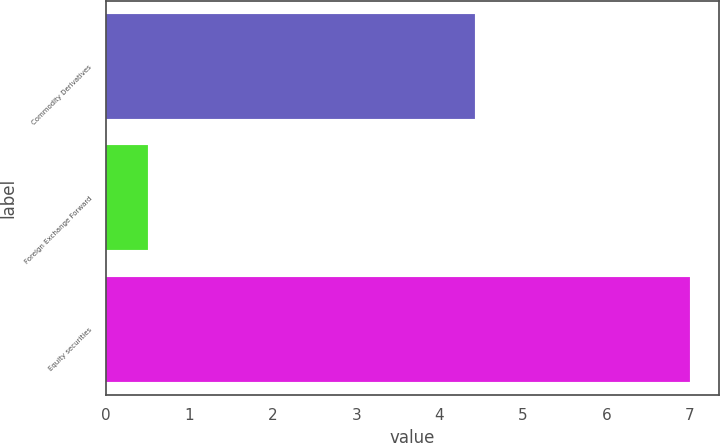Convert chart to OTSL. <chart><loc_0><loc_0><loc_500><loc_500><bar_chart><fcel>Commodity Derivatives<fcel>Foreign Exchange Forward<fcel>Equity securities<nl><fcel>4.43<fcel>0.5<fcel>7<nl></chart> 